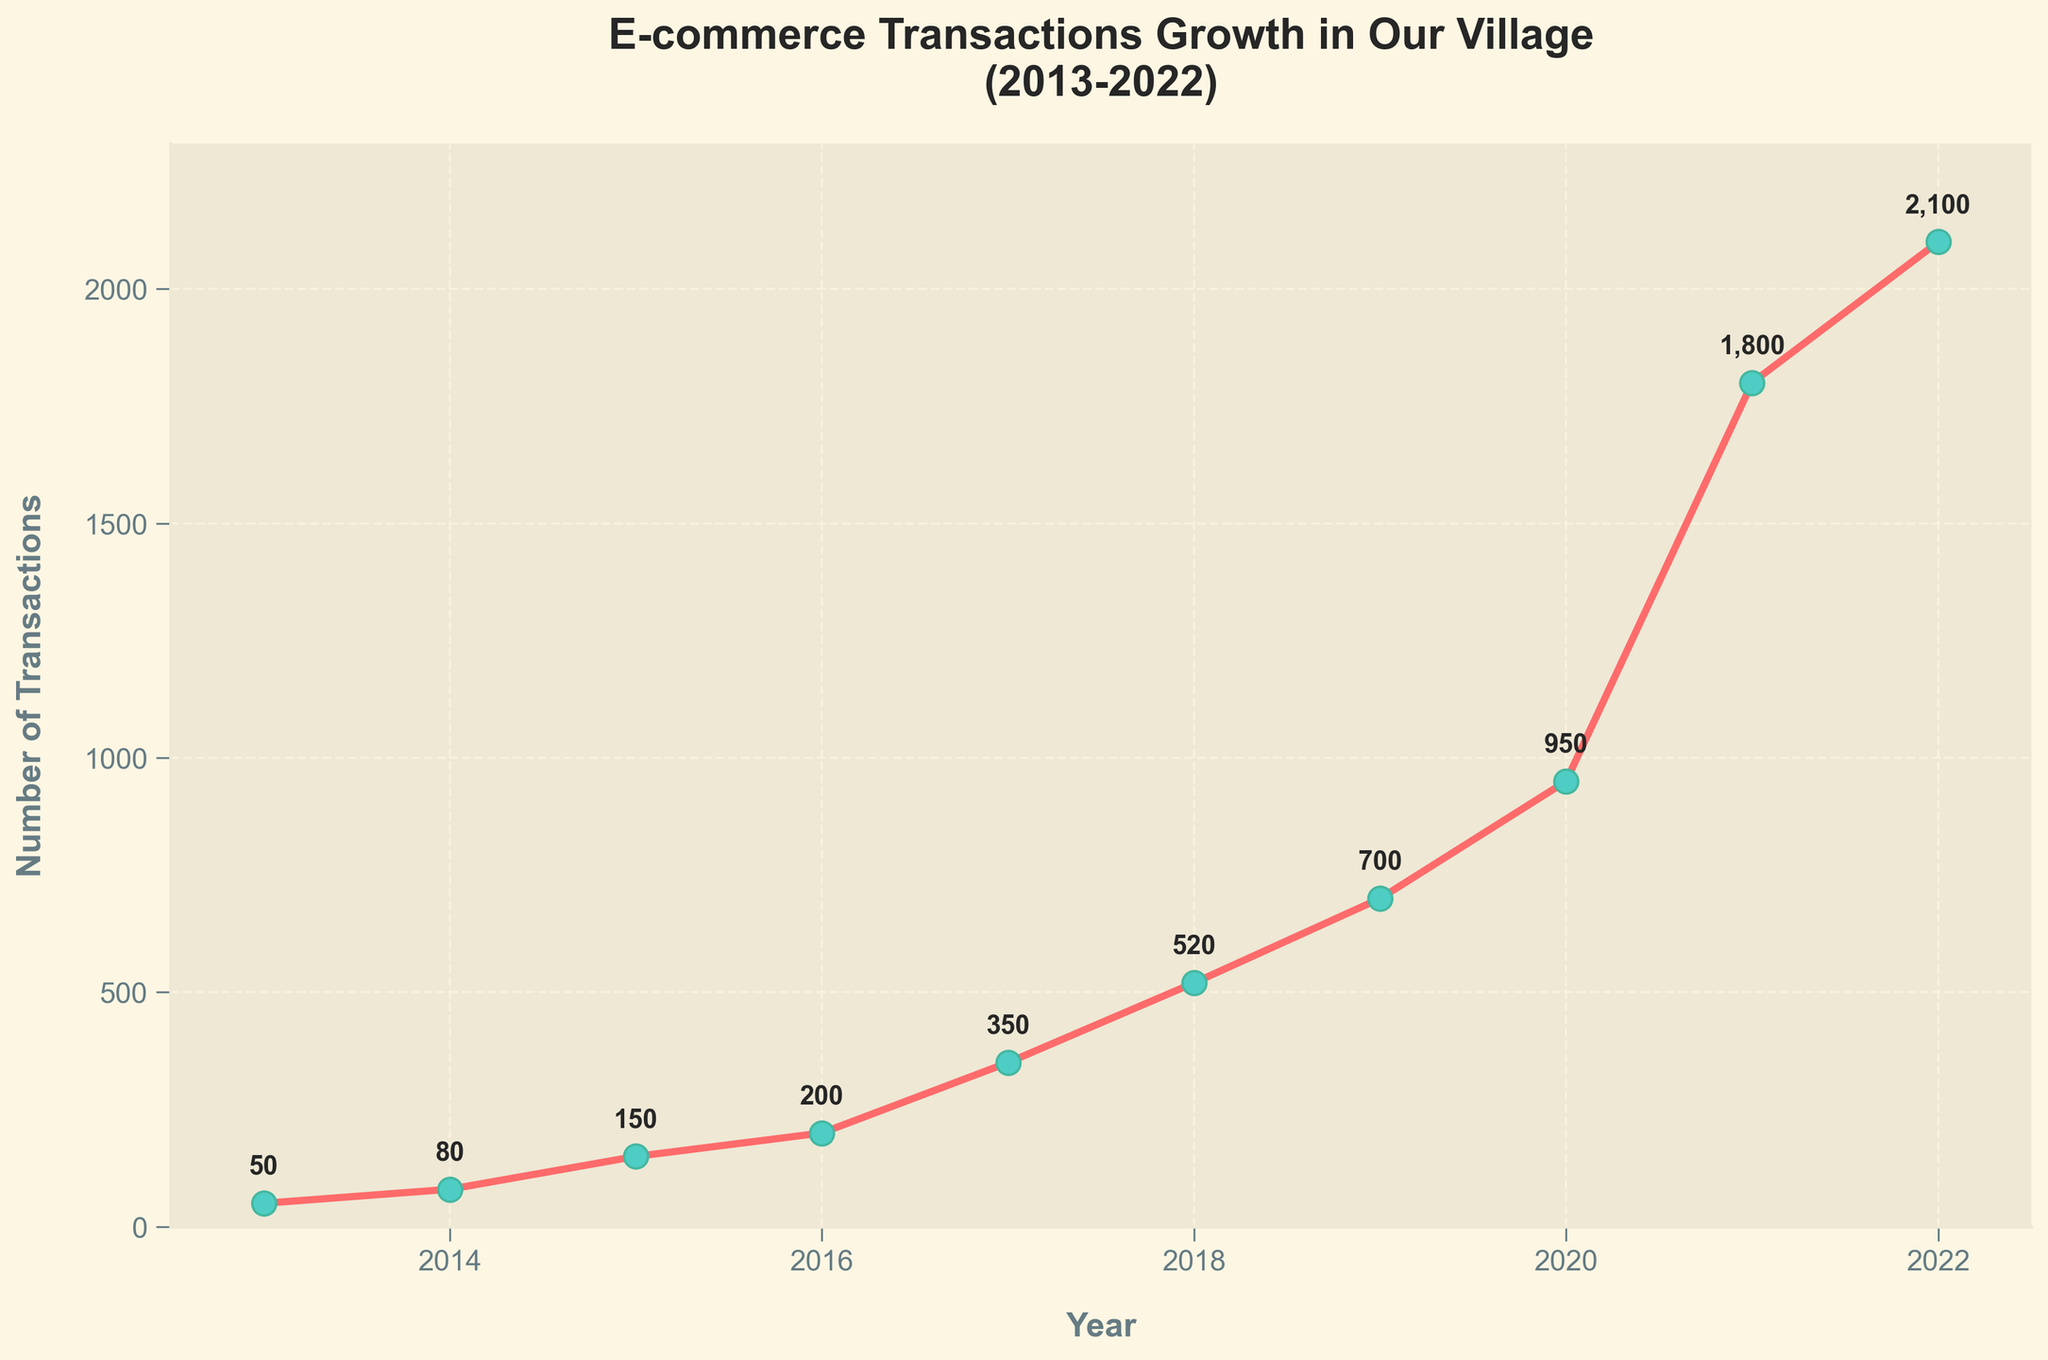What is the title of the plot? The title of the plot is usually located at the top and is often in a larger, bold font to indicate its importance. In this case, the title reads "E-commerce Transactions Growth in Our Village (2013-2022)" as seen at the top of the plot.
Answer: "E-commerce Transactions Growth in Our Village (2013-2022)" How many years of data are displayed in the plot? Counting the number of data points or markers along the x-axis, we see there are data points for each year from 2013 to 2022. There are 10 years represented.
Answer: 10 years What were the number of transactions in the year 2017? Locate the 2017 data point on the x-axis and read the corresponding value on the y-axis, which is also annotated on the plot. The number of transactions in 2017 is annotated as 350.
Answer: 350 By how much did the number of transactions increase from 2016 to 2017? The number of transactions in 2016 is 200, and in 2017 it is 350. The increase is calculated as 350 - 200.
Answer: 150 In which year did the number of transactions first exceed 500? Looking at the y-axis values and corresponding years, the transactions first exceed 500 in 2018, where the value is annotated as 520.
Answer: 2018 What is the average number of transactions from 2013 to 2017? Add the transactions from 2013 to 2017 (50 + 80 + 150 + 200 + 350) and divide by the number of years, which is 5. The total is 830, so the average is 830 / 5.
Answer: 166 Which year experienced the highest jump in transactions compared to the previous year? Calculate the yearly increases and find the maximum. Increases are 30 (2014), 70 (2015), 50 (2016), 150 (2017), 170 (2018), 180 (2019), 250 (2020), 850 (2021), 300 (2022). The highest jump is from 2020 to 2021 which is 850.
Answer: 2021 What is the general trend of e-commerce transactions in the village over the decade? Observing the plot, the trend shows a significant and consistent increase in the number of transactions every year from 2013 to 2022, indicating growing e-commerce adoption in the village.
Answer: Increasing trend 